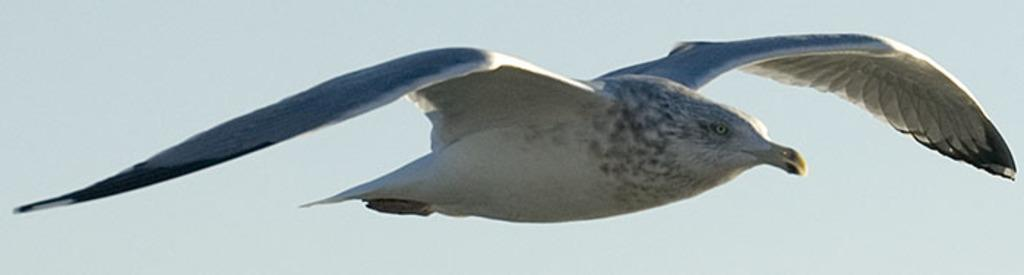What type of animal can be seen in the image? There is a bird in the air in the image. Can you describe the bird's location in the image? The bird is in the air in the image. What type of powder is the grandfather using to influence the government in the image? There is no grandfather, powder, or government present in the image; it only features a bird in the air. 